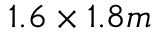<formula> <loc_0><loc_0><loc_500><loc_500>1 . 6 \times 1 . 8 m</formula> 